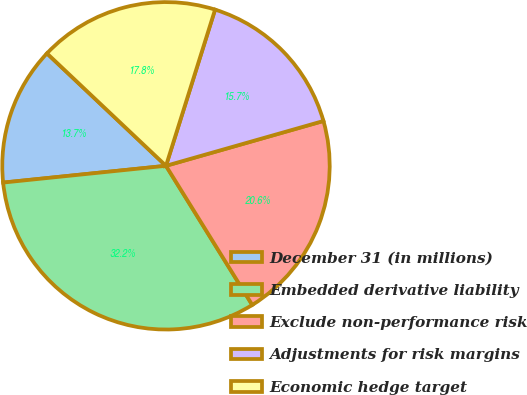Convert chart to OTSL. <chart><loc_0><loc_0><loc_500><loc_500><pie_chart><fcel>December 31 (in millions)<fcel>Embedded derivative liability<fcel>Exclude non-performance risk<fcel>Adjustments for risk margins<fcel>Economic hedge target<nl><fcel>13.68%<fcel>32.2%<fcel>20.58%<fcel>15.74%<fcel>17.8%<nl></chart> 